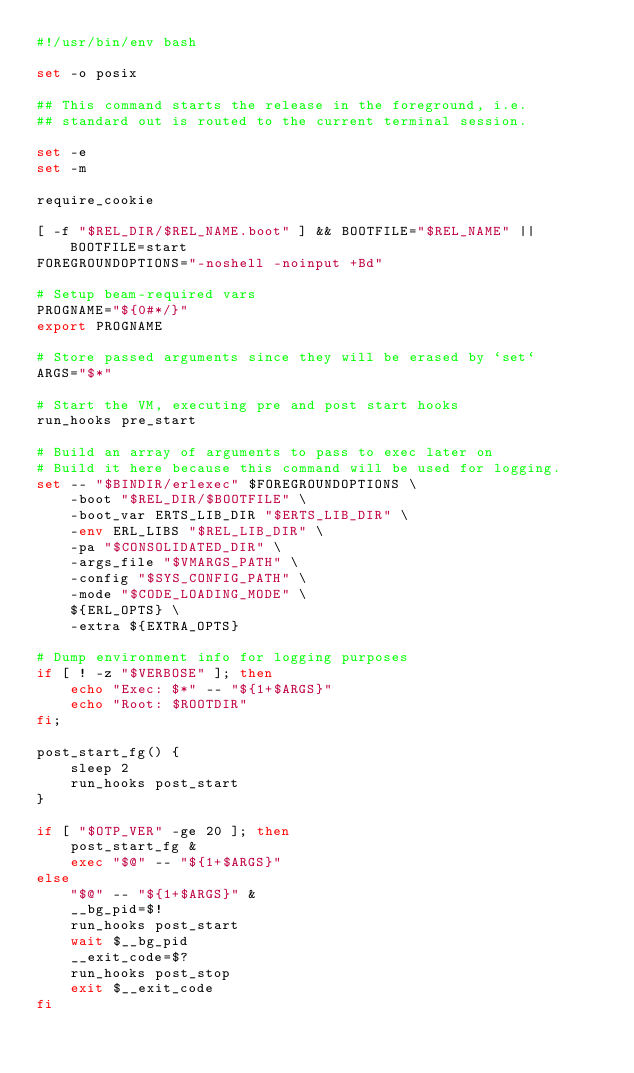<code> <loc_0><loc_0><loc_500><loc_500><_Bash_>#!/usr/bin/env bash

set -o posix

## This command starts the release in the foreground, i.e.
## standard out is routed to the current terminal session.

set -e
set -m

require_cookie

[ -f "$REL_DIR/$REL_NAME.boot" ] && BOOTFILE="$REL_NAME" || BOOTFILE=start
FOREGROUNDOPTIONS="-noshell -noinput +Bd"

# Setup beam-required vars
PROGNAME="${0#*/}"
export PROGNAME

# Store passed arguments since they will be erased by `set`
ARGS="$*"

# Start the VM, executing pre and post start hooks
run_hooks pre_start

# Build an array of arguments to pass to exec later on
# Build it here because this command will be used for logging.
set -- "$BINDIR/erlexec" $FOREGROUNDOPTIONS \
    -boot "$REL_DIR/$BOOTFILE" \
    -boot_var ERTS_LIB_DIR "$ERTS_LIB_DIR" \
    -env ERL_LIBS "$REL_LIB_DIR" \
    -pa "$CONSOLIDATED_DIR" \
    -args_file "$VMARGS_PATH" \
    -config "$SYS_CONFIG_PATH" \
    -mode "$CODE_LOADING_MODE" \
    ${ERL_OPTS} \
    -extra ${EXTRA_OPTS}

# Dump environment info for logging purposes
if [ ! -z "$VERBOSE" ]; then
    echo "Exec: $*" -- "${1+$ARGS}"
    echo "Root: $ROOTDIR"
fi;

post_start_fg() {
    sleep 2
    run_hooks post_start
}

if [ "$OTP_VER" -ge 20 ]; then
    post_start_fg &
    exec "$@" -- "${1+$ARGS}"
else
    "$@" -- "${1+$ARGS}" &
    __bg_pid=$!
    run_hooks post_start
    wait $__bg_pid
    __exit_code=$?
    run_hooks post_stop
    exit $__exit_code
fi
</code> 